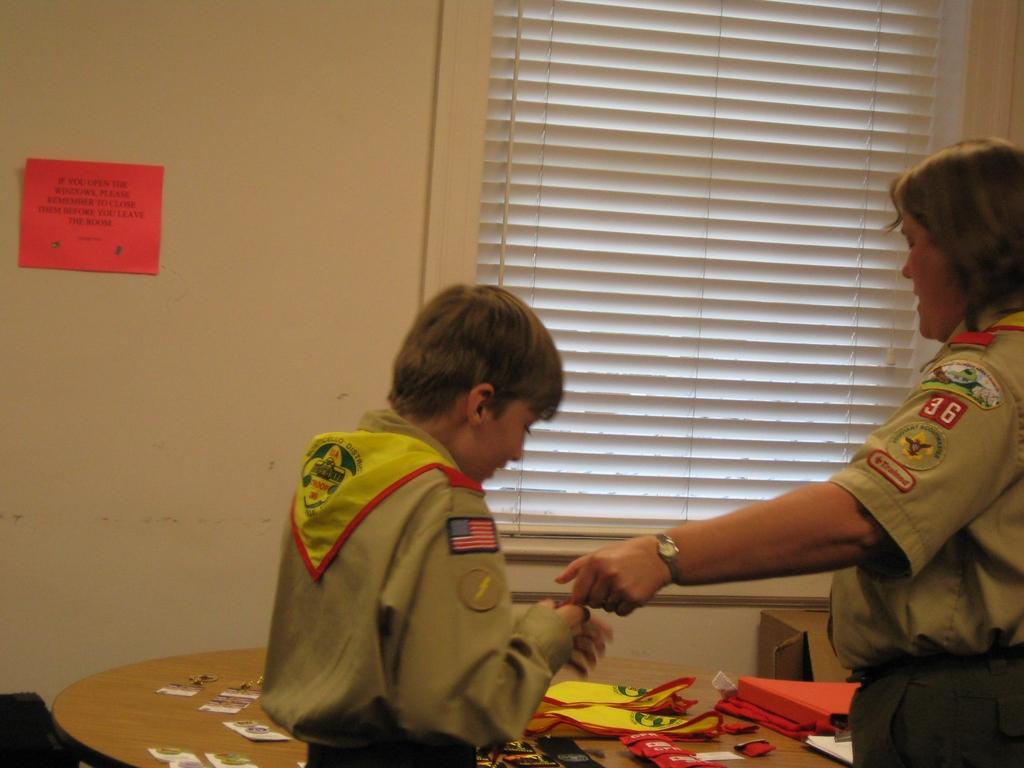How many people are on the floor in the image? There are two persons on the floor in the image. What can be seen in the background of the image? There is a table, papers, a wall, and a window in the background of the image. What type of setting is the image likely taken in? The image is likely taken in a room. What type of hair is visible on the plate in the image? There is no plate or hair present in the image. 